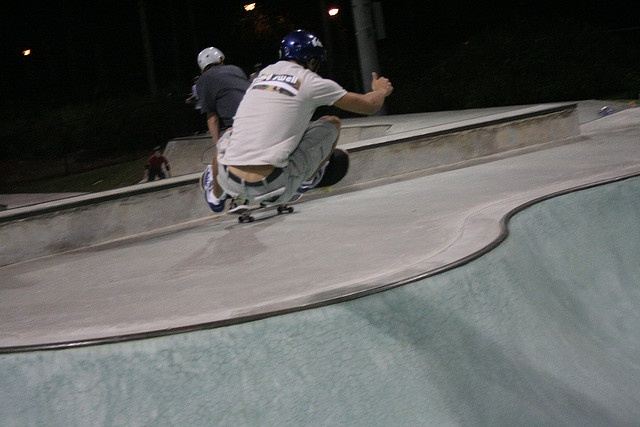Describe the objects in this image and their specific colors. I can see people in black, gray, darkgray, and lightgray tones, people in black, gray, and darkgray tones, skateboard in black and gray tones, skateboard in black, gray, and darkgray tones, and people in black and gray tones in this image. 